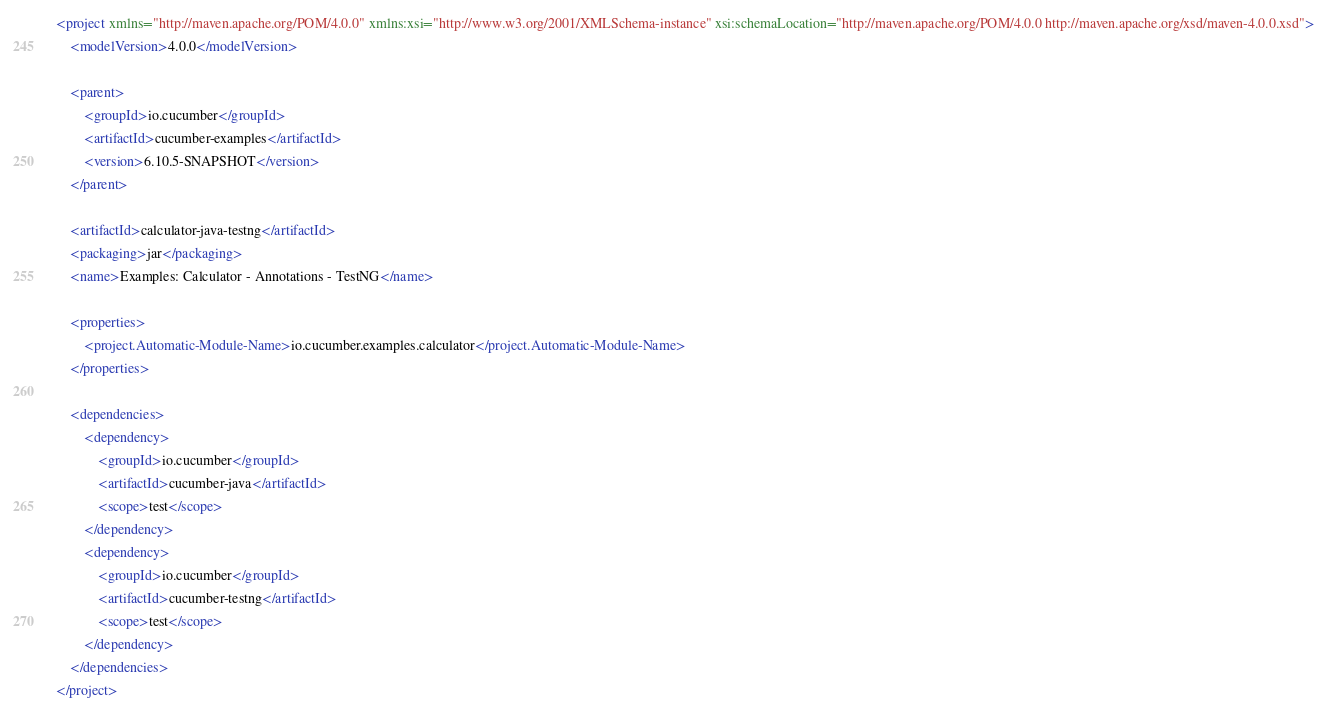Convert code to text. <code><loc_0><loc_0><loc_500><loc_500><_XML_><project xmlns="http://maven.apache.org/POM/4.0.0" xmlns:xsi="http://www.w3.org/2001/XMLSchema-instance" xsi:schemaLocation="http://maven.apache.org/POM/4.0.0 http://maven.apache.org/xsd/maven-4.0.0.xsd">
    <modelVersion>4.0.0</modelVersion>

    <parent>
        <groupId>io.cucumber</groupId>
        <artifactId>cucumber-examples</artifactId>
        <version>6.10.5-SNAPSHOT</version>
    </parent>

    <artifactId>calculator-java-testng</artifactId>
    <packaging>jar</packaging>
    <name>Examples: Calculator - Annotations - TestNG</name>

    <properties>
        <project.Automatic-Module-Name>io.cucumber.examples.calculator</project.Automatic-Module-Name>
    </properties>

    <dependencies>
        <dependency>
            <groupId>io.cucumber</groupId>
            <artifactId>cucumber-java</artifactId>
            <scope>test</scope>
        </dependency>
        <dependency>
            <groupId>io.cucumber</groupId>
            <artifactId>cucumber-testng</artifactId>
            <scope>test</scope>
        </dependency>
    </dependencies>
</project>
</code> 